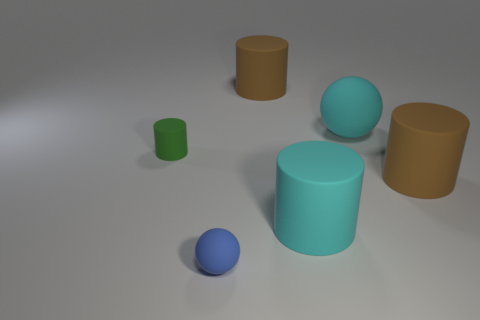Subtract all green cubes. How many brown cylinders are left? 2 Subtract all big cylinders. How many cylinders are left? 1 Add 3 brown rubber objects. How many objects exist? 9 Subtract all purple cylinders. Subtract all yellow balls. How many cylinders are left? 4 Subtract all cylinders. How many objects are left? 2 Subtract all big blue rubber cylinders. Subtract all large objects. How many objects are left? 2 Add 4 brown objects. How many brown objects are left? 6 Add 6 big spheres. How many big spheres exist? 7 Subtract 0 yellow balls. How many objects are left? 6 